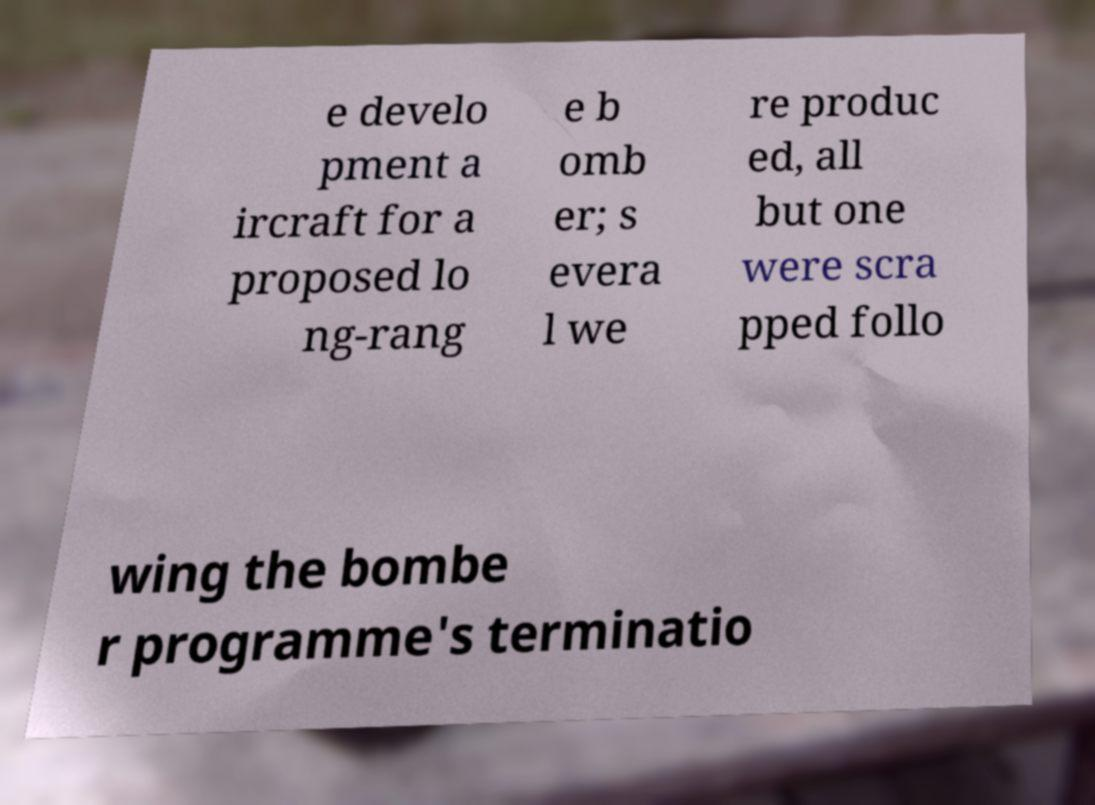Could you assist in decoding the text presented in this image and type it out clearly? e develo pment a ircraft for a proposed lo ng-rang e b omb er; s evera l we re produc ed, all but one were scra pped follo wing the bombe r programme's terminatio 